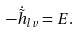Convert formula to latex. <formula><loc_0><loc_0><loc_500><loc_500>- \dot { \tilde { h } } _ { l v } = E .</formula> 